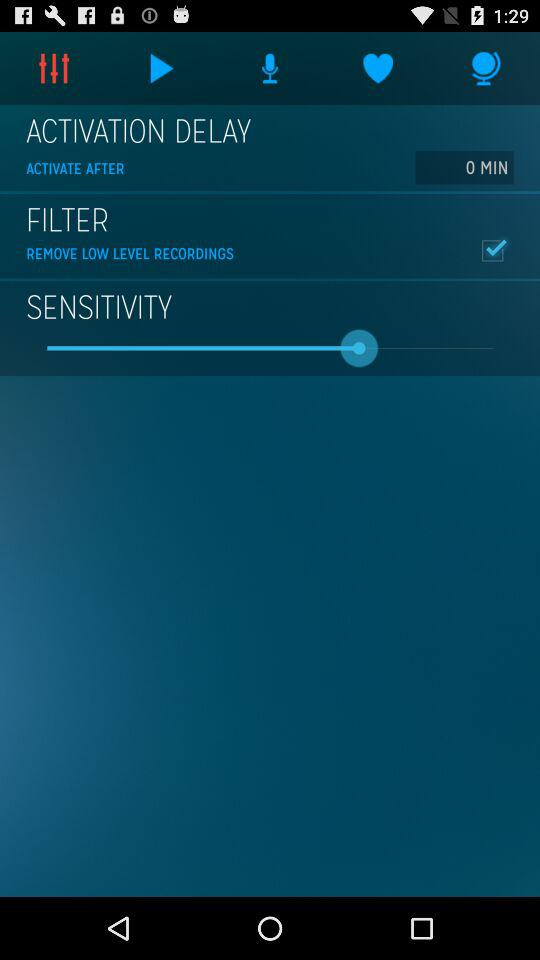What is the time set for "ACTIVATION DELAY"? The time set for "ACTIVATION DELAY" is 0 minutes. 